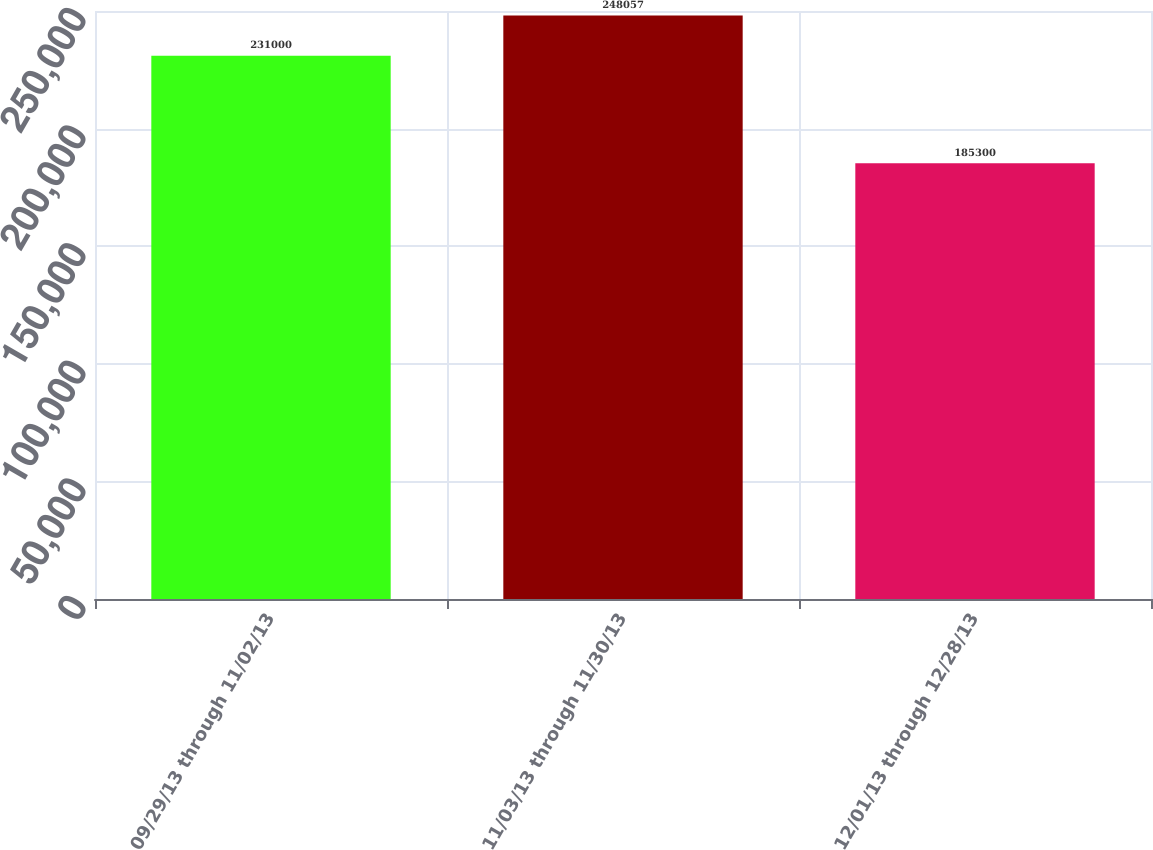<chart> <loc_0><loc_0><loc_500><loc_500><bar_chart><fcel>09/29/13 through 11/02/13<fcel>11/03/13 through 11/30/13<fcel>12/01/13 through 12/28/13<nl><fcel>231000<fcel>248057<fcel>185300<nl></chart> 